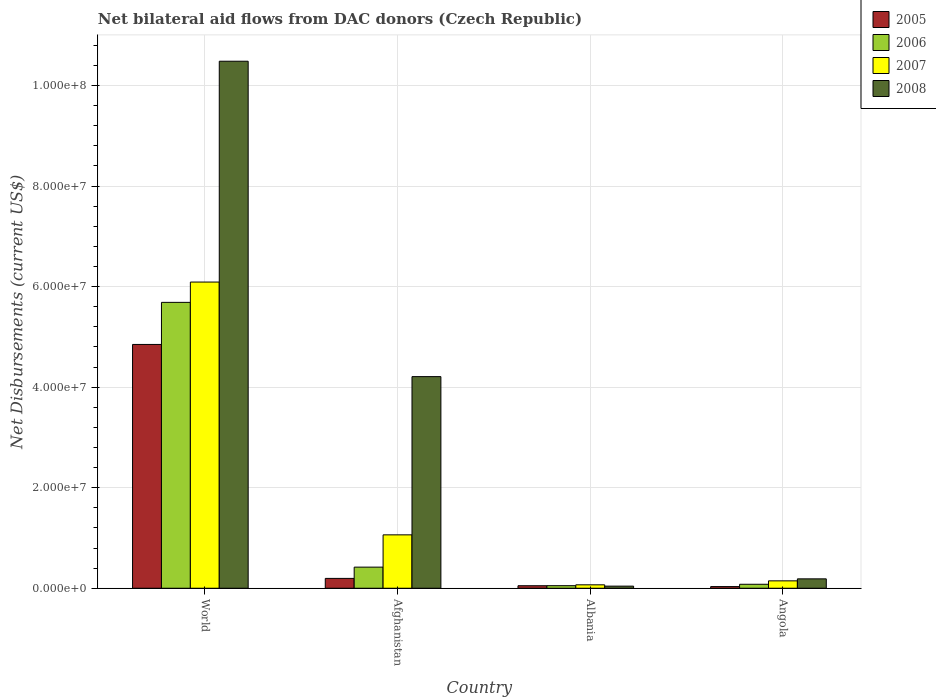How many different coloured bars are there?
Ensure brevity in your answer.  4. How many groups of bars are there?
Provide a short and direct response. 4. Are the number of bars per tick equal to the number of legend labels?
Make the answer very short. Yes. How many bars are there on the 3rd tick from the left?
Make the answer very short. 4. How many bars are there on the 2nd tick from the right?
Offer a terse response. 4. What is the label of the 2nd group of bars from the left?
Provide a short and direct response. Afghanistan. In how many cases, is the number of bars for a given country not equal to the number of legend labels?
Offer a terse response. 0. What is the net bilateral aid flows in 2008 in Angola?
Make the answer very short. 1.87e+06. Across all countries, what is the maximum net bilateral aid flows in 2007?
Offer a terse response. 6.09e+07. Across all countries, what is the minimum net bilateral aid flows in 2007?
Make the answer very short. 6.80e+05. In which country was the net bilateral aid flows in 2007 minimum?
Provide a succinct answer. Albania. What is the total net bilateral aid flows in 2007 in the graph?
Offer a terse response. 7.37e+07. What is the difference between the net bilateral aid flows in 2006 in Albania and that in Angola?
Provide a short and direct response. -2.80e+05. What is the difference between the net bilateral aid flows in 2007 in World and the net bilateral aid flows in 2008 in Afghanistan?
Ensure brevity in your answer.  1.88e+07. What is the average net bilateral aid flows in 2007 per country?
Make the answer very short. 1.84e+07. In how many countries, is the net bilateral aid flows in 2007 greater than 76000000 US$?
Keep it short and to the point. 0. What is the ratio of the net bilateral aid flows in 2006 in Afghanistan to that in World?
Your response must be concise. 0.07. Is the difference between the net bilateral aid flows in 2006 in Afghanistan and World greater than the difference between the net bilateral aid flows in 2005 in Afghanistan and World?
Give a very brief answer. No. What is the difference between the highest and the second highest net bilateral aid flows in 2007?
Provide a succinct answer. 5.94e+07. What is the difference between the highest and the lowest net bilateral aid flows in 2008?
Provide a succinct answer. 1.04e+08. Is it the case that in every country, the sum of the net bilateral aid flows in 2005 and net bilateral aid flows in 2008 is greater than the sum of net bilateral aid flows in 2007 and net bilateral aid flows in 2006?
Offer a terse response. No. How many bars are there?
Provide a short and direct response. 16. How many countries are there in the graph?
Ensure brevity in your answer.  4. Where does the legend appear in the graph?
Your response must be concise. Top right. How many legend labels are there?
Offer a terse response. 4. What is the title of the graph?
Your answer should be compact. Net bilateral aid flows from DAC donors (Czech Republic). What is the label or title of the Y-axis?
Your answer should be compact. Net Disbursements (current US$). What is the Net Disbursements (current US$) in 2005 in World?
Provide a succinct answer. 4.85e+07. What is the Net Disbursements (current US$) of 2006 in World?
Provide a succinct answer. 5.69e+07. What is the Net Disbursements (current US$) of 2007 in World?
Give a very brief answer. 6.09e+07. What is the Net Disbursements (current US$) of 2008 in World?
Provide a short and direct response. 1.05e+08. What is the Net Disbursements (current US$) in 2005 in Afghanistan?
Provide a succinct answer. 1.96e+06. What is the Net Disbursements (current US$) of 2006 in Afghanistan?
Give a very brief answer. 4.20e+06. What is the Net Disbursements (current US$) of 2007 in Afghanistan?
Make the answer very short. 1.06e+07. What is the Net Disbursements (current US$) of 2008 in Afghanistan?
Your answer should be compact. 4.21e+07. What is the Net Disbursements (current US$) in 2005 in Albania?
Ensure brevity in your answer.  5.00e+05. What is the Net Disbursements (current US$) in 2006 in Albania?
Offer a very short reply. 5.10e+05. What is the Net Disbursements (current US$) of 2007 in Albania?
Offer a terse response. 6.80e+05. What is the Net Disbursements (current US$) of 2008 in Albania?
Your response must be concise. 4.20e+05. What is the Net Disbursements (current US$) of 2006 in Angola?
Provide a short and direct response. 7.90e+05. What is the Net Disbursements (current US$) of 2007 in Angola?
Ensure brevity in your answer.  1.47e+06. What is the Net Disbursements (current US$) in 2008 in Angola?
Give a very brief answer. 1.87e+06. Across all countries, what is the maximum Net Disbursements (current US$) in 2005?
Keep it short and to the point. 4.85e+07. Across all countries, what is the maximum Net Disbursements (current US$) in 2006?
Your answer should be very brief. 5.69e+07. Across all countries, what is the maximum Net Disbursements (current US$) of 2007?
Offer a very short reply. 6.09e+07. Across all countries, what is the maximum Net Disbursements (current US$) in 2008?
Keep it short and to the point. 1.05e+08. Across all countries, what is the minimum Net Disbursements (current US$) of 2006?
Give a very brief answer. 5.10e+05. Across all countries, what is the minimum Net Disbursements (current US$) in 2007?
Provide a short and direct response. 6.80e+05. What is the total Net Disbursements (current US$) in 2005 in the graph?
Offer a very short reply. 5.13e+07. What is the total Net Disbursements (current US$) of 2006 in the graph?
Make the answer very short. 6.24e+07. What is the total Net Disbursements (current US$) of 2007 in the graph?
Keep it short and to the point. 7.37e+07. What is the total Net Disbursements (current US$) in 2008 in the graph?
Your answer should be compact. 1.49e+08. What is the difference between the Net Disbursements (current US$) in 2005 in World and that in Afghanistan?
Provide a succinct answer. 4.65e+07. What is the difference between the Net Disbursements (current US$) in 2006 in World and that in Afghanistan?
Make the answer very short. 5.27e+07. What is the difference between the Net Disbursements (current US$) in 2007 in World and that in Afghanistan?
Provide a short and direct response. 5.03e+07. What is the difference between the Net Disbursements (current US$) of 2008 in World and that in Afghanistan?
Offer a very short reply. 6.27e+07. What is the difference between the Net Disbursements (current US$) of 2005 in World and that in Albania?
Offer a terse response. 4.80e+07. What is the difference between the Net Disbursements (current US$) of 2006 in World and that in Albania?
Provide a succinct answer. 5.64e+07. What is the difference between the Net Disbursements (current US$) in 2007 in World and that in Albania?
Offer a terse response. 6.02e+07. What is the difference between the Net Disbursements (current US$) in 2008 in World and that in Albania?
Your response must be concise. 1.04e+08. What is the difference between the Net Disbursements (current US$) in 2005 in World and that in Angola?
Keep it short and to the point. 4.82e+07. What is the difference between the Net Disbursements (current US$) in 2006 in World and that in Angola?
Your answer should be compact. 5.61e+07. What is the difference between the Net Disbursements (current US$) in 2007 in World and that in Angola?
Your answer should be very brief. 5.94e+07. What is the difference between the Net Disbursements (current US$) in 2008 in World and that in Angola?
Make the answer very short. 1.03e+08. What is the difference between the Net Disbursements (current US$) in 2005 in Afghanistan and that in Albania?
Provide a succinct answer. 1.46e+06. What is the difference between the Net Disbursements (current US$) in 2006 in Afghanistan and that in Albania?
Make the answer very short. 3.69e+06. What is the difference between the Net Disbursements (current US$) of 2007 in Afghanistan and that in Albania?
Offer a very short reply. 9.94e+06. What is the difference between the Net Disbursements (current US$) of 2008 in Afghanistan and that in Albania?
Give a very brief answer. 4.17e+07. What is the difference between the Net Disbursements (current US$) in 2005 in Afghanistan and that in Angola?
Provide a short and direct response. 1.63e+06. What is the difference between the Net Disbursements (current US$) in 2006 in Afghanistan and that in Angola?
Your response must be concise. 3.41e+06. What is the difference between the Net Disbursements (current US$) of 2007 in Afghanistan and that in Angola?
Offer a very short reply. 9.15e+06. What is the difference between the Net Disbursements (current US$) of 2008 in Afghanistan and that in Angola?
Ensure brevity in your answer.  4.02e+07. What is the difference between the Net Disbursements (current US$) of 2006 in Albania and that in Angola?
Offer a very short reply. -2.80e+05. What is the difference between the Net Disbursements (current US$) in 2007 in Albania and that in Angola?
Give a very brief answer. -7.90e+05. What is the difference between the Net Disbursements (current US$) of 2008 in Albania and that in Angola?
Ensure brevity in your answer.  -1.45e+06. What is the difference between the Net Disbursements (current US$) of 2005 in World and the Net Disbursements (current US$) of 2006 in Afghanistan?
Your answer should be very brief. 4.43e+07. What is the difference between the Net Disbursements (current US$) in 2005 in World and the Net Disbursements (current US$) in 2007 in Afghanistan?
Keep it short and to the point. 3.79e+07. What is the difference between the Net Disbursements (current US$) in 2005 in World and the Net Disbursements (current US$) in 2008 in Afghanistan?
Provide a succinct answer. 6.40e+06. What is the difference between the Net Disbursements (current US$) in 2006 in World and the Net Disbursements (current US$) in 2007 in Afghanistan?
Provide a succinct answer. 4.62e+07. What is the difference between the Net Disbursements (current US$) in 2006 in World and the Net Disbursements (current US$) in 2008 in Afghanistan?
Provide a short and direct response. 1.48e+07. What is the difference between the Net Disbursements (current US$) of 2007 in World and the Net Disbursements (current US$) of 2008 in Afghanistan?
Your answer should be compact. 1.88e+07. What is the difference between the Net Disbursements (current US$) of 2005 in World and the Net Disbursements (current US$) of 2006 in Albania?
Your answer should be very brief. 4.80e+07. What is the difference between the Net Disbursements (current US$) in 2005 in World and the Net Disbursements (current US$) in 2007 in Albania?
Make the answer very short. 4.78e+07. What is the difference between the Net Disbursements (current US$) of 2005 in World and the Net Disbursements (current US$) of 2008 in Albania?
Keep it short and to the point. 4.81e+07. What is the difference between the Net Disbursements (current US$) in 2006 in World and the Net Disbursements (current US$) in 2007 in Albania?
Provide a succinct answer. 5.62e+07. What is the difference between the Net Disbursements (current US$) in 2006 in World and the Net Disbursements (current US$) in 2008 in Albania?
Offer a terse response. 5.64e+07. What is the difference between the Net Disbursements (current US$) of 2007 in World and the Net Disbursements (current US$) of 2008 in Albania?
Your answer should be very brief. 6.05e+07. What is the difference between the Net Disbursements (current US$) in 2005 in World and the Net Disbursements (current US$) in 2006 in Angola?
Provide a succinct answer. 4.77e+07. What is the difference between the Net Disbursements (current US$) in 2005 in World and the Net Disbursements (current US$) in 2007 in Angola?
Your answer should be very brief. 4.70e+07. What is the difference between the Net Disbursements (current US$) of 2005 in World and the Net Disbursements (current US$) of 2008 in Angola?
Offer a very short reply. 4.66e+07. What is the difference between the Net Disbursements (current US$) of 2006 in World and the Net Disbursements (current US$) of 2007 in Angola?
Your response must be concise. 5.54e+07. What is the difference between the Net Disbursements (current US$) of 2006 in World and the Net Disbursements (current US$) of 2008 in Angola?
Your answer should be compact. 5.50e+07. What is the difference between the Net Disbursements (current US$) in 2007 in World and the Net Disbursements (current US$) in 2008 in Angola?
Make the answer very short. 5.90e+07. What is the difference between the Net Disbursements (current US$) of 2005 in Afghanistan and the Net Disbursements (current US$) of 2006 in Albania?
Ensure brevity in your answer.  1.45e+06. What is the difference between the Net Disbursements (current US$) in 2005 in Afghanistan and the Net Disbursements (current US$) in 2007 in Albania?
Your answer should be very brief. 1.28e+06. What is the difference between the Net Disbursements (current US$) of 2005 in Afghanistan and the Net Disbursements (current US$) of 2008 in Albania?
Ensure brevity in your answer.  1.54e+06. What is the difference between the Net Disbursements (current US$) in 2006 in Afghanistan and the Net Disbursements (current US$) in 2007 in Albania?
Keep it short and to the point. 3.52e+06. What is the difference between the Net Disbursements (current US$) in 2006 in Afghanistan and the Net Disbursements (current US$) in 2008 in Albania?
Provide a succinct answer. 3.78e+06. What is the difference between the Net Disbursements (current US$) of 2007 in Afghanistan and the Net Disbursements (current US$) of 2008 in Albania?
Your answer should be compact. 1.02e+07. What is the difference between the Net Disbursements (current US$) in 2005 in Afghanistan and the Net Disbursements (current US$) in 2006 in Angola?
Ensure brevity in your answer.  1.17e+06. What is the difference between the Net Disbursements (current US$) of 2005 in Afghanistan and the Net Disbursements (current US$) of 2007 in Angola?
Give a very brief answer. 4.90e+05. What is the difference between the Net Disbursements (current US$) in 2006 in Afghanistan and the Net Disbursements (current US$) in 2007 in Angola?
Ensure brevity in your answer.  2.73e+06. What is the difference between the Net Disbursements (current US$) of 2006 in Afghanistan and the Net Disbursements (current US$) of 2008 in Angola?
Your answer should be compact. 2.33e+06. What is the difference between the Net Disbursements (current US$) in 2007 in Afghanistan and the Net Disbursements (current US$) in 2008 in Angola?
Offer a very short reply. 8.75e+06. What is the difference between the Net Disbursements (current US$) of 2005 in Albania and the Net Disbursements (current US$) of 2006 in Angola?
Your response must be concise. -2.90e+05. What is the difference between the Net Disbursements (current US$) of 2005 in Albania and the Net Disbursements (current US$) of 2007 in Angola?
Your answer should be very brief. -9.70e+05. What is the difference between the Net Disbursements (current US$) of 2005 in Albania and the Net Disbursements (current US$) of 2008 in Angola?
Ensure brevity in your answer.  -1.37e+06. What is the difference between the Net Disbursements (current US$) of 2006 in Albania and the Net Disbursements (current US$) of 2007 in Angola?
Make the answer very short. -9.60e+05. What is the difference between the Net Disbursements (current US$) in 2006 in Albania and the Net Disbursements (current US$) in 2008 in Angola?
Offer a very short reply. -1.36e+06. What is the difference between the Net Disbursements (current US$) in 2007 in Albania and the Net Disbursements (current US$) in 2008 in Angola?
Your answer should be very brief. -1.19e+06. What is the average Net Disbursements (current US$) of 2005 per country?
Provide a succinct answer. 1.28e+07. What is the average Net Disbursements (current US$) of 2006 per country?
Make the answer very short. 1.56e+07. What is the average Net Disbursements (current US$) in 2007 per country?
Make the answer very short. 1.84e+07. What is the average Net Disbursements (current US$) in 2008 per country?
Your answer should be very brief. 3.73e+07. What is the difference between the Net Disbursements (current US$) in 2005 and Net Disbursements (current US$) in 2006 in World?
Provide a succinct answer. -8.37e+06. What is the difference between the Net Disbursements (current US$) in 2005 and Net Disbursements (current US$) in 2007 in World?
Ensure brevity in your answer.  -1.24e+07. What is the difference between the Net Disbursements (current US$) of 2005 and Net Disbursements (current US$) of 2008 in World?
Offer a very short reply. -5.63e+07. What is the difference between the Net Disbursements (current US$) of 2006 and Net Disbursements (current US$) of 2007 in World?
Your response must be concise. -4.04e+06. What is the difference between the Net Disbursements (current US$) of 2006 and Net Disbursements (current US$) of 2008 in World?
Your answer should be very brief. -4.80e+07. What is the difference between the Net Disbursements (current US$) of 2007 and Net Disbursements (current US$) of 2008 in World?
Provide a short and direct response. -4.39e+07. What is the difference between the Net Disbursements (current US$) in 2005 and Net Disbursements (current US$) in 2006 in Afghanistan?
Offer a very short reply. -2.24e+06. What is the difference between the Net Disbursements (current US$) in 2005 and Net Disbursements (current US$) in 2007 in Afghanistan?
Provide a succinct answer. -8.66e+06. What is the difference between the Net Disbursements (current US$) in 2005 and Net Disbursements (current US$) in 2008 in Afghanistan?
Keep it short and to the point. -4.01e+07. What is the difference between the Net Disbursements (current US$) of 2006 and Net Disbursements (current US$) of 2007 in Afghanistan?
Your answer should be compact. -6.42e+06. What is the difference between the Net Disbursements (current US$) in 2006 and Net Disbursements (current US$) in 2008 in Afghanistan?
Ensure brevity in your answer.  -3.79e+07. What is the difference between the Net Disbursements (current US$) in 2007 and Net Disbursements (current US$) in 2008 in Afghanistan?
Offer a terse response. -3.15e+07. What is the difference between the Net Disbursements (current US$) of 2006 and Net Disbursements (current US$) of 2007 in Albania?
Keep it short and to the point. -1.70e+05. What is the difference between the Net Disbursements (current US$) in 2007 and Net Disbursements (current US$) in 2008 in Albania?
Offer a terse response. 2.60e+05. What is the difference between the Net Disbursements (current US$) of 2005 and Net Disbursements (current US$) of 2006 in Angola?
Your answer should be compact. -4.60e+05. What is the difference between the Net Disbursements (current US$) of 2005 and Net Disbursements (current US$) of 2007 in Angola?
Make the answer very short. -1.14e+06. What is the difference between the Net Disbursements (current US$) in 2005 and Net Disbursements (current US$) in 2008 in Angola?
Provide a short and direct response. -1.54e+06. What is the difference between the Net Disbursements (current US$) in 2006 and Net Disbursements (current US$) in 2007 in Angola?
Make the answer very short. -6.80e+05. What is the difference between the Net Disbursements (current US$) in 2006 and Net Disbursements (current US$) in 2008 in Angola?
Your answer should be very brief. -1.08e+06. What is the difference between the Net Disbursements (current US$) in 2007 and Net Disbursements (current US$) in 2008 in Angola?
Your answer should be very brief. -4.00e+05. What is the ratio of the Net Disbursements (current US$) in 2005 in World to that in Afghanistan?
Keep it short and to the point. 24.74. What is the ratio of the Net Disbursements (current US$) of 2006 in World to that in Afghanistan?
Keep it short and to the point. 13.54. What is the ratio of the Net Disbursements (current US$) of 2007 in World to that in Afghanistan?
Your answer should be very brief. 5.74. What is the ratio of the Net Disbursements (current US$) of 2008 in World to that in Afghanistan?
Provide a short and direct response. 2.49. What is the ratio of the Net Disbursements (current US$) of 2005 in World to that in Albania?
Your answer should be compact. 97. What is the ratio of the Net Disbursements (current US$) in 2006 in World to that in Albania?
Your response must be concise. 111.51. What is the ratio of the Net Disbursements (current US$) of 2007 in World to that in Albania?
Provide a short and direct response. 89.57. What is the ratio of the Net Disbursements (current US$) of 2008 in World to that in Albania?
Ensure brevity in your answer.  249.62. What is the ratio of the Net Disbursements (current US$) in 2005 in World to that in Angola?
Provide a short and direct response. 146.97. What is the ratio of the Net Disbursements (current US$) of 2006 in World to that in Angola?
Give a very brief answer. 71.99. What is the ratio of the Net Disbursements (current US$) of 2007 in World to that in Angola?
Your answer should be compact. 41.44. What is the ratio of the Net Disbursements (current US$) of 2008 in World to that in Angola?
Give a very brief answer. 56.06. What is the ratio of the Net Disbursements (current US$) in 2005 in Afghanistan to that in Albania?
Provide a succinct answer. 3.92. What is the ratio of the Net Disbursements (current US$) in 2006 in Afghanistan to that in Albania?
Give a very brief answer. 8.24. What is the ratio of the Net Disbursements (current US$) of 2007 in Afghanistan to that in Albania?
Provide a short and direct response. 15.62. What is the ratio of the Net Disbursements (current US$) in 2008 in Afghanistan to that in Albania?
Provide a succinct answer. 100.24. What is the ratio of the Net Disbursements (current US$) of 2005 in Afghanistan to that in Angola?
Your response must be concise. 5.94. What is the ratio of the Net Disbursements (current US$) of 2006 in Afghanistan to that in Angola?
Keep it short and to the point. 5.32. What is the ratio of the Net Disbursements (current US$) in 2007 in Afghanistan to that in Angola?
Keep it short and to the point. 7.22. What is the ratio of the Net Disbursements (current US$) of 2008 in Afghanistan to that in Angola?
Offer a terse response. 22.51. What is the ratio of the Net Disbursements (current US$) in 2005 in Albania to that in Angola?
Your answer should be compact. 1.52. What is the ratio of the Net Disbursements (current US$) of 2006 in Albania to that in Angola?
Keep it short and to the point. 0.65. What is the ratio of the Net Disbursements (current US$) of 2007 in Albania to that in Angola?
Offer a terse response. 0.46. What is the ratio of the Net Disbursements (current US$) of 2008 in Albania to that in Angola?
Ensure brevity in your answer.  0.22. What is the difference between the highest and the second highest Net Disbursements (current US$) of 2005?
Provide a succinct answer. 4.65e+07. What is the difference between the highest and the second highest Net Disbursements (current US$) in 2006?
Provide a succinct answer. 5.27e+07. What is the difference between the highest and the second highest Net Disbursements (current US$) in 2007?
Offer a terse response. 5.03e+07. What is the difference between the highest and the second highest Net Disbursements (current US$) of 2008?
Offer a terse response. 6.27e+07. What is the difference between the highest and the lowest Net Disbursements (current US$) in 2005?
Make the answer very short. 4.82e+07. What is the difference between the highest and the lowest Net Disbursements (current US$) in 2006?
Ensure brevity in your answer.  5.64e+07. What is the difference between the highest and the lowest Net Disbursements (current US$) in 2007?
Your answer should be very brief. 6.02e+07. What is the difference between the highest and the lowest Net Disbursements (current US$) of 2008?
Offer a very short reply. 1.04e+08. 